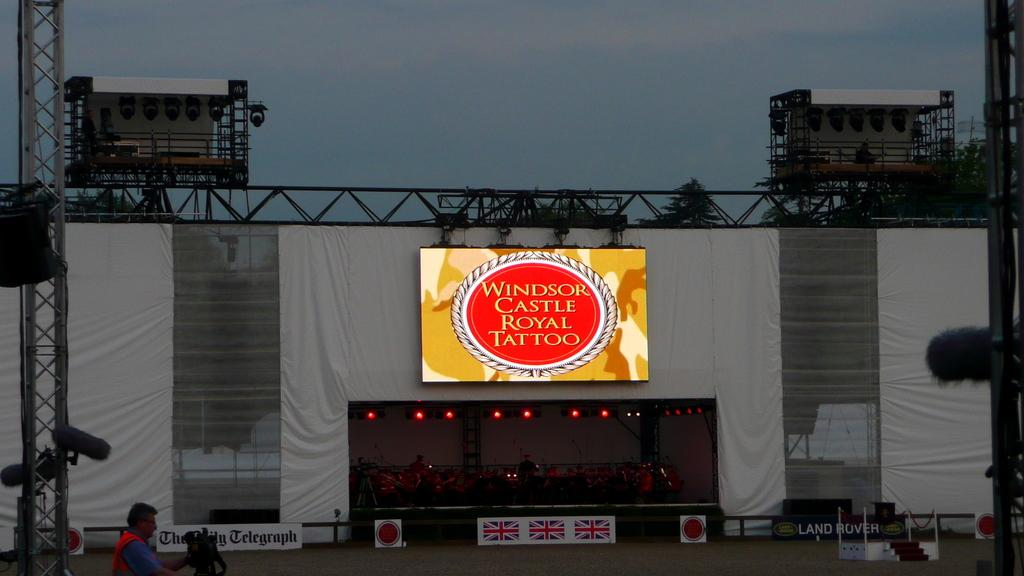<image>
Write a terse but informative summary of the picture. A large outdoor venue with Windsor Castle Royal Tattoo on top of the stage area. 